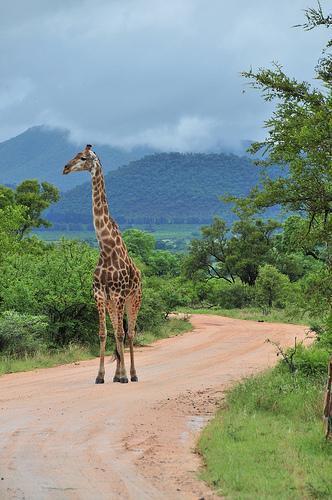How many giraffe are shown?
Give a very brief answer. 1. 